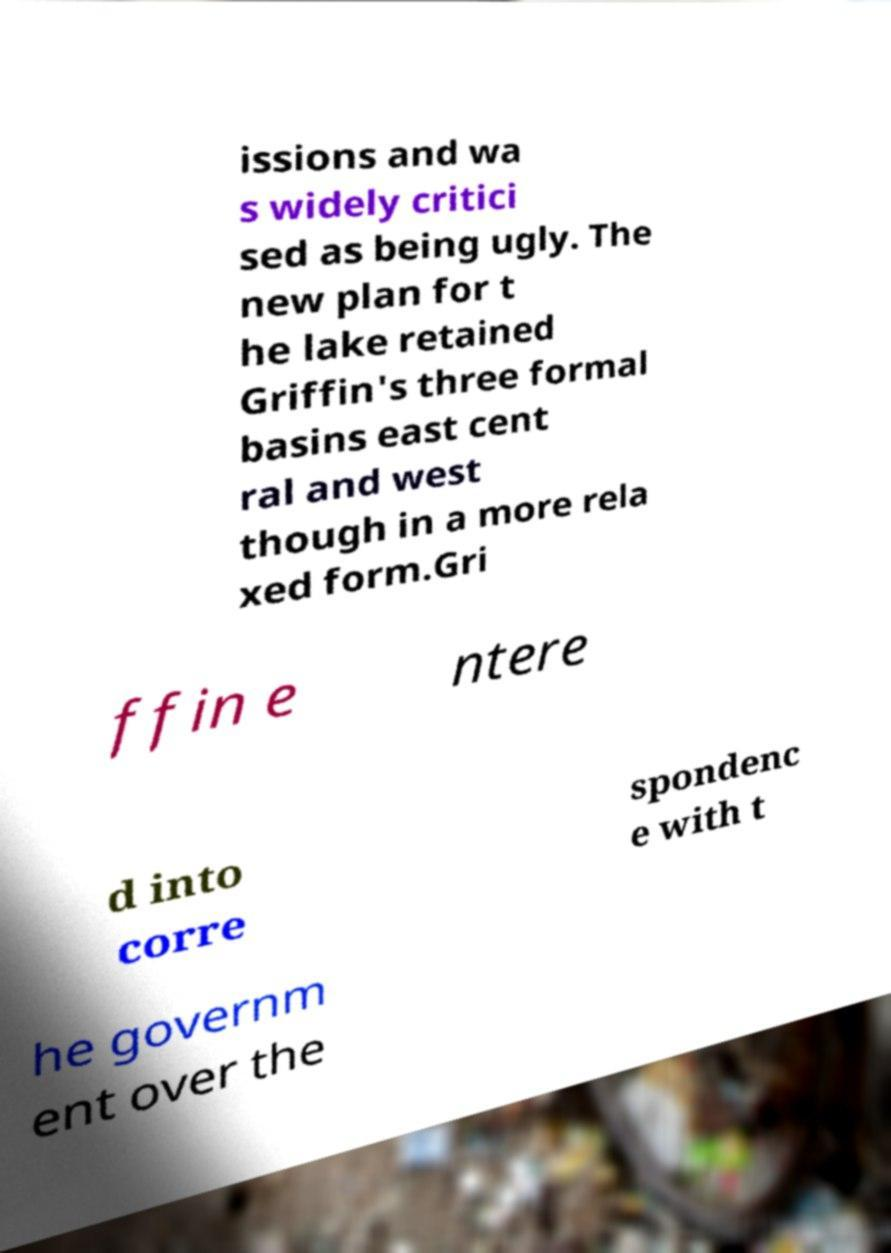Could you assist in decoding the text presented in this image and type it out clearly? issions and wa s widely critici sed as being ugly. The new plan for t he lake retained Griffin's three formal basins east cent ral and west though in a more rela xed form.Gri ffin e ntere d into corre spondenc e with t he governm ent over the 